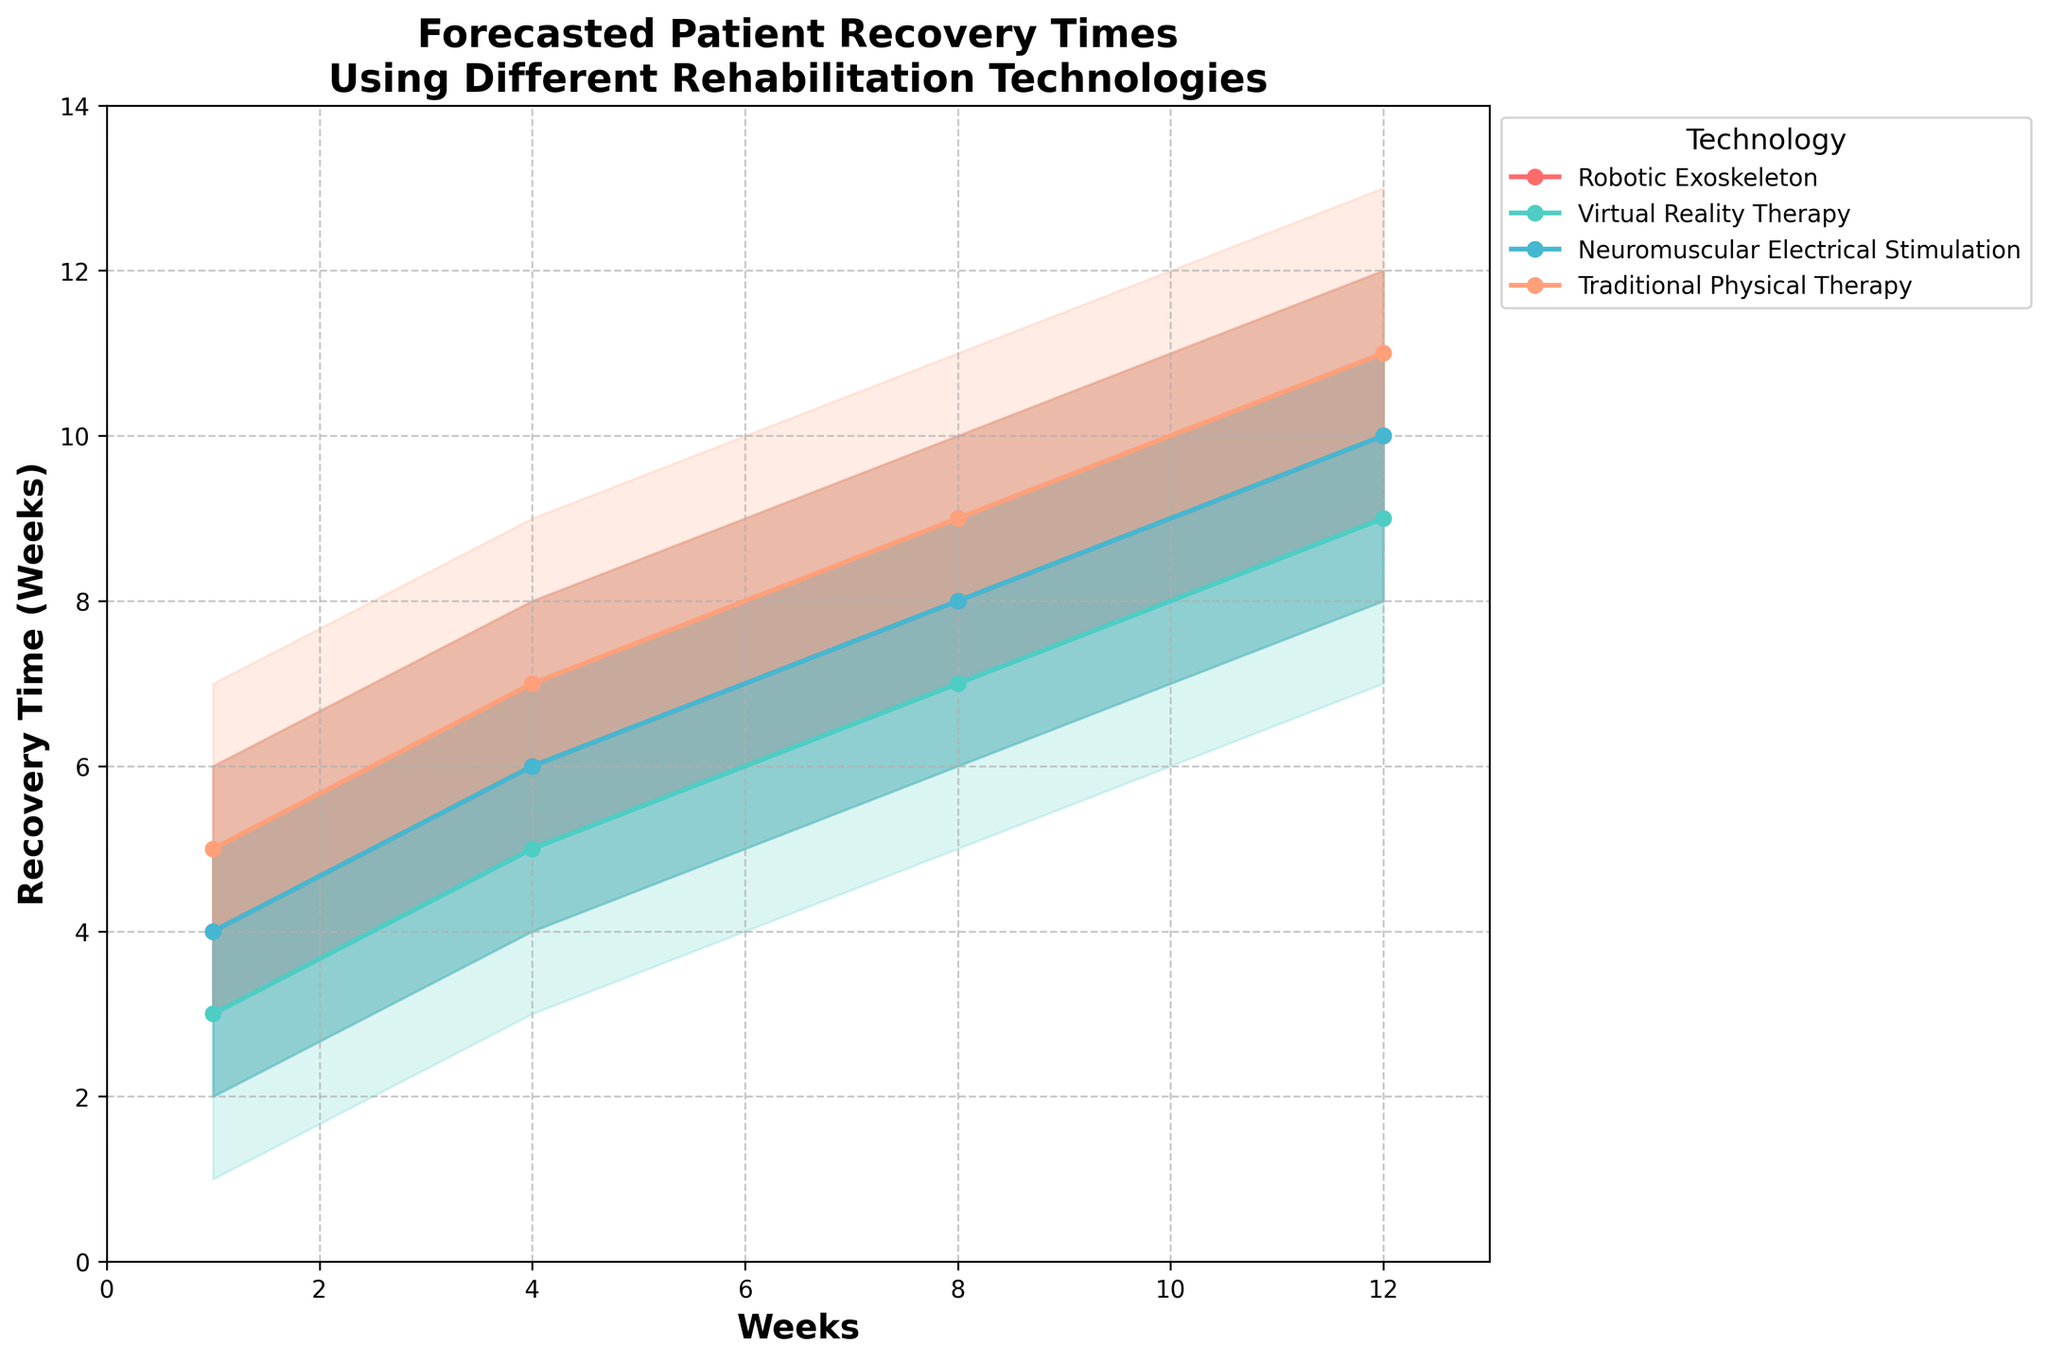What is the title of the figure? The title is usually at the top of the figure in a larger font size and bold for emphasis. For this figure, it reads "Forecasted Patient Recovery Times\nUsing Different Rehabilitation Technologies".
Answer: Forecasted Patient Recovery Times\nUsing Different Rehabilitation Technologies How many weeks are considered in the recovery time forecasts for all technologies? The x-axis represents weeks, ranging from 0 to 13. Looking at the axis ticks and the data points plotted, the weeks interval is 1, 4, 8, and 12.
Answer: 4 distinct points (1, 4, 8, 12) Which rehabilitation technology shows the fastest recovery time at the 50% confidence level at week 1? The 50% confidence lines for each technology are marked with different colors and points. At week 1, Virtual Reality Therapy shows the fastest recovery time as its 50% confidence level is at 3 weeks.
Answer: Virtual Reality Therapy Which technology has the widest range between the 10% and 90% confidence intervals at week 12? The range between 10% and 90% confidence intervals for each technology can be identified by noting the filled areas. At week 12, Traditional Physical Therapy shows the widest range, from 9 weeks (10%) to 13 weeks (90%).
Answer: Traditional Physical Therapy How does the recovery time forecast for Robotic Exoskeleton change from week 1 to week 12 at the 25% confidence level? To find the changes, compare the 25% confidence recovery times at weeks 1 and 12 for Robotic Exoskeleton. At week 1, the 25% confidence level is 3 weeks, and at week 12, it is 9 weeks.
Answer: Increases from 3 weeks to 9 weeks What is the median (50% confidence level) recovery time for Neuromuscular Electrical Stimulation at week 4? Review the plots and markers for Neuromuscular Electrical Stimulation at week 4, the specified median recovery time is 6 weeks.
Answer: 6 weeks Which technology shows a consistent increase in recovery time forecasts across all weeks at the 75% confidence level? By examining the 75% confidence level line for each technology, we observe that Traditional Physical Therapy consistently increases across all weeks (6, 8, 10, 12 weeks for 1, 4, 8, 12 weeks respectively).
Answer: Traditional Physical Therapy At week 8, how does the 50% confidence level recovery time for Robotic Exoskeleton compare to Virtual Reality Therapy? The 50% confidence level for Robotic Exoskeleton is 8 weeks at week 8, while for Virtual Reality Therapy, it is 7 weeks.
Answer: Robotic Exoskeleton is 1 week longer Which technology shows the least variation between the 25% and 75% confidence intervals at week 1? By comparing the filled areas between the 25% and 75% confidence intervals at week 1, Virtual Reality Therapy shows the least variation ranging from 2 to 4 weeks.
Answer: Virtual Reality Therapy 